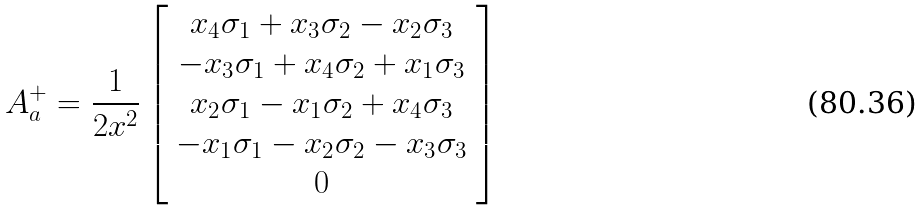<formula> <loc_0><loc_0><loc_500><loc_500>A _ { a } ^ { + } = \frac { 1 } { 2 x ^ { 2 } } \left [ \begin{array} { c } x _ { 4 } \sigma _ { 1 } + x _ { 3 } \sigma _ { 2 } - x _ { 2 } \sigma _ { 3 } \\ - x _ { 3 } \sigma _ { 1 } + x _ { 4 } \sigma _ { 2 } + x _ { 1 } \sigma _ { 3 } \\ x _ { 2 } \sigma _ { 1 } - x _ { 1 } \sigma _ { 2 } + x _ { 4 } \sigma _ { 3 } \\ - x _ { 1 } \sigma _ { 1 } - x _ { 2 } \sigma _ { 2 } - x _ { 3 } \sigma _ { 3 } \\ 0 \end{array} \right ]</formula> 